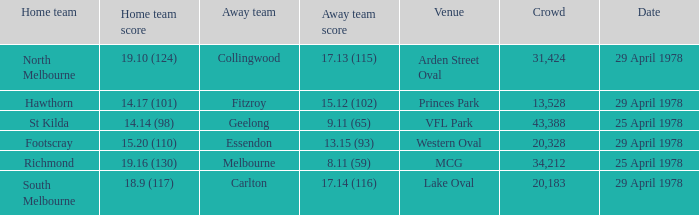What was the away team that played at Princes Park? Fitzroy. 